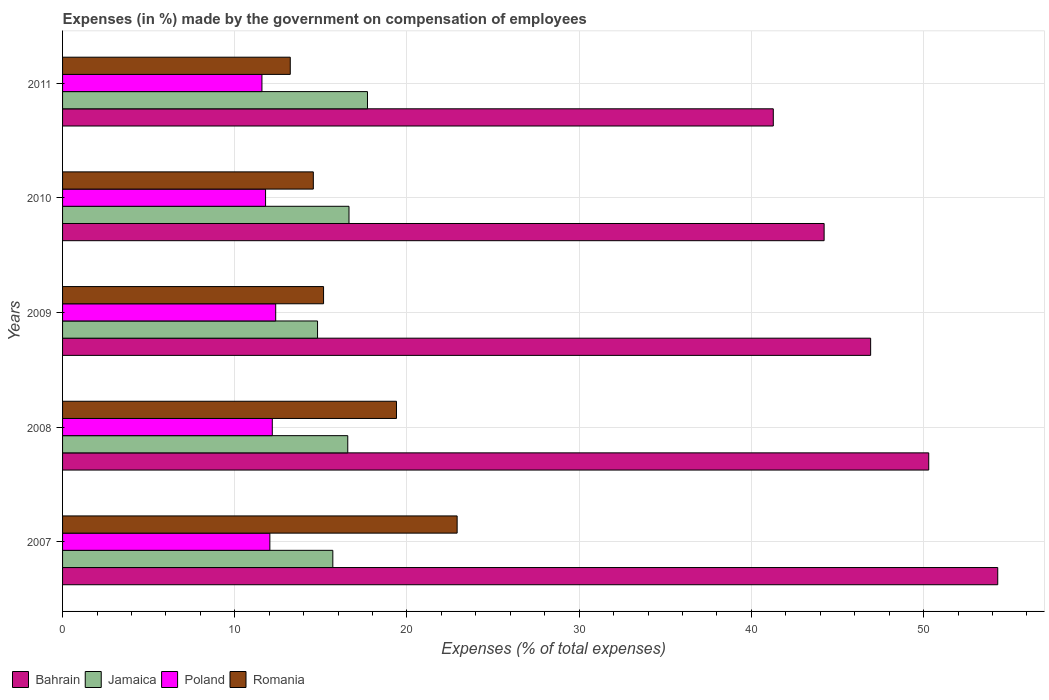How many different coloured bars are there?
Your response must be concise. 4. How many groups of bars are there?
Give a very brief answer. 5. Are the number of bars per tick equal to the number of legend labels?
Your answer should be compact. Yes. Are the number of bars on each tick of the Y-axis equal?
Ensure brevity in your answer.  Yes. How many bars are there on the 2nd tick from the top?
Your response must be concise. 4. In how many cases, is the number of bars for a given year not equal to the number of legend labels?
Offer a terse response. 0. What is the percentage of expenses made by the government on compensation of employees in Bahrain in 2009?
Offer a very short reply. 46.93. Across all years, what is the maximum percentage of expenses made by the government on compensation of employees in Jamaica?
Make the answer very short. 17.71. Across all years, what is the minimum percentage of expenses made by the government on compensation of employees in Bahrain?
Provide a succinct answer. 41.27. What is the total percentage of expenses made by the government on compensation of employees in Poland in the graph?
Provide a succinct answer. 59.96. What is the difference between the percentage of expenses made by the government on compensation of employees in Romania in 2008 and that in 2011?
Offer a very short reply. 6.17. What is the difference between the percentage of expenses made by the government on compensation of employees in Poland in 2010 and the percentage of expenses made by the government on compensation of employees in Romania in 2007?
Provide a short and direct response. -11.13. What is the average percentage of expenses made by the government on compensation of employees in Bahrain per year?
Offer a very short reply. 47.41. In the year 2011, what is the difference between the percentage of expenses made by the government on compensation of employees in Bahrain and percentage of expenses made by the government on compensation of employees in Romania?
Offer a terse response. 28.05. What is the ratio of the percentage of expenses made by the government on compensation of employees in Jamaica in 2009 to that in 2011?
Provide a short and direct response. 0.84. Is the difference between the percentage of expenses made by the government on compensation of employees in Bahrain in 2008 and 2010 greater than the difference between the percentage of expenses made by the government on compensation of employees in Romania in 2008 and 2010?
Your answer should be very brief. Yes. What is the difference between the highest and the second highest percentage of expenses made by the government on compensation of employees in Poland?
Provide a short and direct response. 0.2. What is the difference between the highest and the lowest percentage of expenses made by the government on compensation of employees in Poland?
Give a very brief answer. 0.8. In how many years, is the percentage of expenses made by the government on compensation of employees in Poland greater than the average percentage of expenses made by the government on compensation of employees in Poland taken over all years?
Your answer should be compact. 3. Is the sum of the percentage of expenses made by the government on compensation of employees in Romania in 2008 and 2009 greater than the maximum percentage of expenses made by the government on compensation of employees in Bahrain across all years?
Your answer should be compact. No. How many bars are there?
Ensure brevity in your answer.  20. Are all the bars in the graph horizontal?
Your answer should be compact. Yes. How many years are there in the graph?
Your answer should be very brief. 5. What is the difference between two consecutive major ticks on the X-axis?
Provide a short and direct response. 10. Does the graph contain any zero values?
Provide a succinct answer. No. How are the legend labels stacked?
Make the answer very short. Horizontal. What is the title of the graph?
Offer a very short reply. Expenses (in %) made by the government on compensation of employees. What is the label or title of the X-axis?
Offer a terse response. Expenses (% of total expenses). What is the label or title of the Y-axis?
Your answer should be compact. Years. What is the Expenses (% of total expenses) of Bahrain in 2007?
Ensure brevity in your answer.  54.31. What is the Expenses (% of total expenses) in Jamaica in 2007?
Make the answer very short. 15.69. What is the Expenses (% of total expenses) in Poland in 2007?
Give a very brief answer. 12.04. What is the Expenses (% of total expenses) in Romania in 2007?
Offer a very short reply. 22.91. What is the Expenses (% of total expenses) of Bahrain in 2008?
Offer a very short reply. 50.3. What is the Expenses (% of total expenses) of Jamaica in 2008?
Give a very brief answer. 16.56. What is the Expenses (% of total expenses) in Poland in 2008?
Your answer should be very brief. 12.18. What is the Expenses (% of total expenses) in Romania in 2008?
Your response must be concise. 19.39. What is the Expenses (% of total expenses) of Bahrain in 2009?
Offer a terse response. 46.93. What is the Expenses (% of total expenses) in Jamaica in 2009?
Keep it short and to the point. 14.81. What is the Expenses (% of total expenses) in Poland in 2009?
Offer a very short reply. 12.38. What is the Expenses (% of total expenses) of Romania in 2009?
Offer a very short reply. 15.16. What is the Expenses (% of total expenses) in Bahrain in 2010?
Give a very brief answer. 44.22. What is the Expenses (% of total expenses) of Jamaica in 2010?
Offer a very short reply. 16.63. What is the Expenses (% of total expenses) of Poland in 2010?
Ensure brevity in your answer.  11.79. What is the Expenses (% of total expenses) in Romania in 2010?
Your answer should be very brief. 14.56. What is the Expenses (% of total expenses) of Bahrain in 2011?
Provide a short and direct response. 41.27. What is the Expenses (% of total expenses) of Jamaica in 2011?
Your response must be concise. 17.71. What is the Expenses (% of total expenses) in Poland in 2011?
Provide a succinct answer. 11.58. What is the Expenses (% of total expenses) of Romania in 2011?
Provide a succinct answer. 13.22. Across all years, what is the maximum Expenses (% of total expenses) in Bahrain?
Your response must be concise. 54.31. Across all years, what is the maximum Expenses (% of total expenses) of Jamaica?
Offer a very short reply. 17.71. Across all years, what is the maximum Expenses (% of total expenses) in Poland?
Give a very brief answer. 12.38. Across all years, what is the maximum Expenses (% of total expenses) of Romania?
Ensure brevity in your answer.  22.91. Across all years, what is the minimum Expenses (% of total expenses) of Bahrain?
Offer a terse response. 41.27. Across all years, what is the minimum Expenses (% of total expenses) in Jamaica?
Your answer should be very brief. 14.81. Across all years, what is the minimum Expenses (% of total expenses) in Poland?
Your answer should be compact. 11.58. Across all years, what is the minimum Expenses (% of total expenses) of Romania?
Your answer should be very brief. 13.22. What is the total Expenses (% of total expenses) in Bahrain in the graph?
Ensure brevity in your answer.  237.03. What is the total Expenses (% of total expenses) of Jamaica in the graph?
Make the answer very short. 81.4. What is the total Expenses (% of total expenses) in Poland in the graph?
Your answer should be compact. 59.96. What is the total Expenses (% of total expenses) in Romania in the graph?
Keep it short and to the point. 85.24. What is the difference between the Expenses (% of total expenses) of Bahrain in 2007 and that in 2008?
Your answer should be compact. 4.01. What is the difference between the Expenses (% of total expenses) of Jamaica in 2007 and that in 2008?
Ensure brevity in your answer.  -0.87. What is the difference between the Expenses (% of total expenses) of Poland in 2007 and that in 2008?
Give a very brief answer. -0.14. What is the difference between the Expenses (% of total expenses) of Romania in 2007 and that in 2008?
Your response must be concise. 3.52. What is the difference between the Expenses (% of total expenses) in Bahrain in 2007 and that in 2009?
Keep it short and to the point. 7.38. What is the difference between the Expenses (% of total expenses) of Jamaica in 2007 and that in 2009?
Give a very brief answer. 0.89. What is the difference between the Expenses (% of total expenses) in Poland in 2007 and that in 2009?
Your response must be concise. -0.34. What is the difference between the Expenses (% of total expenses) of Romania in 2007 and that in 2009?
Provide a short and direct response. 7.76. What is the difference between the Expenses (% of total expenses) in Bahrain in 2007 and that in 2010?
Make the answer very short. 10.08. What is the difference between the Expenses (% of total expenses) of Jamaica in 2007 and that in 2010?
Offer a terse response. -0.94. What is the difference between the Expenses (% of total expenses) in Poland in 2007 and that in 2010?
Offer a terse response. 0.25. What is the difference between the Expenses (% of total expenses) of Romania in 2007 and that in 2010?
Give a very brief answer. 8.35. What is the difference between the Expenses (% of total expenses) of Bahrain in 2007 and that in 2011?
Provide a succinct answer. 13.03. What is the difference between the Expenses (% of total expenses) of Jamaica in 2007 and that in 2011?
Keep it short and to the point. -2.01. What is the difference between the Expenses (% of total expenses) in Poland in 2007 and that in 2011?
Your response must be concise. 0.46. What is the difference between the Expenses (% of total expenses) in Romania in 2007 and that in 2011?
Provide a short and direct response. 9.69. What is the difference between the Expenses (% of total expenses) in Bahrain in 2008 and that in 2009?
Provide a succinct answer. 3.37. What is the difference between the Expenses (% of total expenses) in Jamaica in 2008 and that in 2009?
Your answer should be compact. 1.75. What is the difference between the Expenses (% of total expenses) of Poland in 2008 and that in 2009?
Give a very brief answer. -0.2. What is the difference between the Expenses (% of total expenses) in Romania in 2008 and that in 2009?
Ensure brevity in your answer.  4.23. What is the difference between the Expenses (% of total expenses) in Bahrain in 2008 and that in 2010?
Offer a terse response. 6.08. What is the difference between the Expenses (% of total expenses) of Jamaica in 2008 and that in 2010?
Keep it short and to the point. -0.07. What is the difference between the Expenses (% of total expenses) in Poland in 2008 and that in 2010?
Offer a terse response. 0.39. What is the difference between the Expenses (% of total expenses) in Romania in 2008 and that in 2010?
Keep it short and to the point. 4.83. What is the difference between the Expenses (% of total expenses) in Bahrain in 2008 and that in 2011?
Give a very brief answer. 9.03. What is the difference between the Expenses (% of total expenses) of Jamaica in 2008 and that in 2011?
Give a very brief answer. -1.15. What is the difference between the Expenses (% of total expenses) of Poland in 2008 and that in 2011?
Provide a short and direct response. 0.6. What is the difference between the Expenses (% of total expenses) of Romania in 2008 and that in 2011?
Your answer should be very brief. 6.17. What is the difference between the Expenses (% of total expenses) in Bahrain in 2009 and that in 2010?
Provide a short and direct response. 2.7. What is the difference between the Expenses (% of total expenses) of Jamaica in 2009 and that in 2010?
Your answer should be compact. -1.83. What is the difference between the Expenses (% of total expenses) in Poland in 2009 and that in 2010?
Give a very brief answer. 0.59. What is the difference between the Expenses (% of total expenses) of Romania in 2009 and that in 2010?
Your answer should be very brief. 0.59. What is the difference between the Expenses (% of total expenses) of Bahrain in 2009 and that in 2011?
Your answer should be compact. 5.65. What is the difference between the Expenses (% of total expenses) of Poland in 2009 and that in 2011?
Offer a terse response. 0.8. What is the difference between the Expenses (% of total expenses) of Romania in 2009 and that in 2011?
Your response must be concise. 1.93. What is the difference between the Expenses (% of total expenses) in Bahrain in 2010 and that in 2011?
Your response must be concise. 2.95. What is the difference between the Expenses (% of total expenses) of Jamaica in 2010 and that in 2011?
Provide a short and direct response. -1.07. What is the difference between the Expenses (% of total expenses) of Poland in 2010 and that in 2011?
Make the answer very short. 0.21. What is the difference between the Expenses (% of total expenses) in Romania in 2010 and that in 2011?
Offer a very short reply. 1.34. What is the difference between the Expenses (% of total expenses) in Bahrain in 2007 and the Expenses (% of total expenses) in Jamaica in 2008?
Provide a short and direct response. 37.74. What is the difference between the Expenses (% of total expenses) in Bahrain in 2007 and the Expenses (% of total expenses) in Poland in 2008?
Your response must be concise. 42.13. What is the difference between the Expenses (% of total expenses) of Bahrain in 2007 and the Expenses (% of total expenses) of Romania in 2008?
Offer a very short reply. 34.92. What is the difference between the Expenses (% of total expenses) in Jamaica in 2007 and the Expenses (% of total expenses) in Poland in 2008?
Your response must be concise. 3.52. What is the difference between the Expenses (% of total expenses) of Jamaica in 2007 and the Expenses (% of total expenses) of Romania in 2008?
Provide a succinct answer. -3.7. What is the difference between the Expenses (% of total expenses) in Poland in 2007 and the Expenses (% of total expenses) in Romania in 2008?
Provide a succinct answer. -7.35. What is the difference between the Expenses (% of total expenses) in Bahrain in 2007 and the Expenses (% of total expenses) in Jamaica in 2009?
Offer a very short reply. 39.5. What is the difference between the Expenses (% of total expenses) in Bahrain in 2007 and the Expenses (% of total expenses) in Poland in 2009?
Your answer should be very brief. 41.93. What is the difference between the Expenses (% of total expenses) in Bahrain in 2007 and the Expenses (% of total expenses) in Romania in 2009?
Give a very brief answer. 39.15. What is the difference between the Expenses (% of total expenses) in Jamaica in 2007 and the Expenses (% of total expenses) in Poland in 2009?
Your response must be concise. 3.32. What is the difference between the Expenses (% of total expenses) of Jamaica in 2007 and the Expenses (% of total expenses) of Romania in 2009?
Provide a short and direct response. 0.54. What is the difference between the Expenses (% of total expenses) of Poland in 2007 and the Expenses (% of total expenses) of Romania in 2009?
Provide a succinct answer. -3.12. What is the difference between the Expenses (% of total expenses) of Bahrain in 2007 and the Expenses (% of total expenses) of Jamaica in 2010?
Your answer should be very brief. 37.67. What is the difference between the Expenses (% of total expenses) of Bahrain in 2007 and the Expenses (% of total expenses) of Poland in 2010?
Ensure brevity in your answer.  42.52. What is the difference between the Expenses (% of total expenses) of Bahrain in 2007 and the Expenses (% of total expenses) of Romania in 2010?
Provide a succinct answer. 39.74. What is the difference between the Expenses (% of total expenses) of Jamaica in 2007 and the Expenses (% of total expenses) of Poland in 2010?
Keep it short and to the point. 3.91. What is the difference between the Expenses (% of total expenses) of Jamaica in 2007 and the Expenses (% of total expenses) of Romania in 2010?
Your answer should be very brief. 1.13. What is the difference between the Expenses (% of total expenses) in Poland in 2007 and the Expenses (% of total expenses) in Romania in 2010?
Give a very brief answer. -2.52. What is the difference between the Expenses (% of total expenses) in Bahrain in 2007 and the Expenses (% of total expenses) in Jamaica in 2011?
Make the answer very short. 36.6. What is the difference between the Expenses (% of total expenses) of Bahrain in 2007 and the Expenses (% of total expenses) of Poland in 2011?
Provide a short and direct response. 42.73. What is the difference between the Expenses (% of total expenses) in Bahrain in 2007 and the Expenses (% of total expenses) in Romania in 2011?
Provide a short and direct response. 41.08. What is the difference between the Expenses (% of total expenses) of Jamaica in 2007 and the Expenses (% of total expenses) of Poland in 2011?
Make the answer very short. 4.12. What is the difference between the Expenses (% of total expenses) of Jamaica in 2007 and the Expenses (% of total expenses) of Romania in 2011?
Your answer should be very brief. 2.47. What is the difference between the Expenses (% of total expenses) in Poland in 2007 and the Expenses (% of total expenses) in Romania in 2011?
Your answer should be compact. -1.19. What is the difference between the Expenses (% of total expenses) in Bahrain in 2008 and the Expenses (% of total expenses) in Jamaica in 2009?
Your response must be concise. 35.49. What is the difference between the Expenses (% of total expenses) in Bahrain in 2008 and the Expenses (% of total expenses) in Poland in 2009?
Your answer should be compact. 37.92. What is the difference between the Expenses (% of total expenses) in Bahrain in 2008 and the Expenses (% of total expenses) in Romania in 2009?
Your answer should be very brief. 35.14. What is the difference between the Expenses (% of total expenses) in Jamaica in 2008 and the Expenses (% of total expenses) in Poland in 2009?
Your response must be concise. 4.18. What is the difference between the Expenses (% of total expenses) in Jamaica in 2008 and the Expenses (% of total expenses) in Romania in 2009?
Provide a succinct answer. 1.41. What is the difference between the Expenses (% of total expenses) of Poland in 2008 and the Expenses (% of total expenses) of Romania in 2009?
Provide a short and direct response. -2.98. What is the difference between the Expenses (% of total expenses) in Bahrain in 2008 and the Expenses (% of total expenses) in Jamaica in 2010?
Offer a very short reply. 33.67. What is the difference between the Expenses (% of total expenses) in Bahrain in 2008 and the Expenses (% of total expenses) in Poland in 2010?
Provide a succinct answer. 38.51. What is the difference between the Expenses (% of total expenses) in Bahrain in 2008 and the Expenses (% of total expenses) in Romania in 2010?
Your answer should be compact. 35.74. What is the difference between the Expenses (% of total expenses) in Jamaica in 2008 and the Expenses (% of total expenses) in Poland in 2010?
Keep it short and to the point. 4.77. What is the difference between the Expenses (% of total expenses) in Jamaica in 2008 and the Expenses (% of total expenses) in Romania in 2010?
Provide a short and direct response. 2. What is the difference between the Expenses (% of total expenses) of Poland in 2008 and the Expenses (% of total expenses) of Romania in 2010?
Provide a succinct answer. -2.38. What is the difference between the Expenses (% of total expenses) in Bahrain in 2008 and the Expenses (% of total expenses) in Jamaica in 2011?
Your answer should be compact. 32.59. What is the difference between the Expenses (% of total expenses) of Bahrain in 2008 and the Expenses (% of total expenses) of Poland in 2011?
Ensure brevity in your answer.  38.72. What is the difference between the Expenses (% of total expenses) of Bahrain in 2008 and the Expenses (% of total expenses) of Romania in 2011?
Make the answer very short. 37.08. What is the difference between the Expenses (% of total expenses) in Jamaica in 2008 and the Expenses (% of total expenses) in Poland in 2011?
Provide a short and direct response. 4.98. What is the difference between the Expenses (% of total expenses) in Jamaica in 2008 and the Expenses (% of total expenses) in Romania in 2011?
Your answer should be very brief. 3.34. What is the difference between the Expenses (% of total expenses) of Poland in 2008 and the Expenses (% of total expenses) of Romania in 2011?
Keep it short and to the point. -1.04. What is the difference between the Expenses (% of total expenses) in Bahrain in 2009 and the Expenses (% of total expenses) in Jamaica in 2010?
Your answer should be very brief. 30.29. What is the difference between the Expenses (% of total expenses) of Bahrain in 2009 and the Expenses (% of total expenses) of Poland in 2010?
Provide a succinct answer. 35.14. What is the difference between the Expenses (% of total expenses) in Bahrain in 2009 and the Expenses (% of total expenses) in Romania in 2010?
Ensure brevity in your answer.  32.36. What is the difference between the Expenses (% of total expenses) of Jamaica in 2009 and the Expenses (% of total expenses) of Poland in 2010?
Provide a short and direct response. 3.02. What is the difference between the Expenses (% of total expenses) of Jamaica in 2009 and the Expenses (% of total expenses) of Romania in 2010?
Provide a short and direct response. 0.25. What is the difference between the Expenses (% of total expenses) of Poland in 2009 and the Expenses (% of total expenses) of Romania in 2010?
Your response must be concise. -2.18. What is the difference between the Expenses (% of total expenses) in Bahrain in 2009 and the Expenses (% of total expenses) in Jamaica in 2011?
Make the answer very short. 29.22. What is the difference between the Expenses (% of total expenses) of Bahrain in 2009 and the Expenses (% of total expenses) of Poland in 2011?
Your response must be concise. 35.35. What is the difference between the Expenses (% of total expenses) in Bahrain in 2009 and the Expenses (% of total expenses) in Romania in 2011?
Ensure brevity in your answer.  33.7. What is the difference between the Expenses (% of total expenses) of Jamaica in 2009 and the Expenses (% of total expenses) of Poland in 2011?
Offer a very short reply. 3.23. What is the difference between the Expenses (% of total expenses) in Jamaica in 2009 and the Expenses (% of total expenses) in Romania in 2011?
Keep it short and to the point. 1.58. What is the difference between the Expenses (% of total expenses) of Poland in 2009 and the Expenses (% of total expenses) of Romania in 2011?
Provide a succinct answer. -0.85. What is the difference between the Expenses (% of total expenses) of Bahrain in 2010 and the Expenses (% of total expenses) of Jamaica in 2011?
Ensure brevity in your answer.  26.52. What is the difference between the Expenses (% of total expenses) of Bahrain in 2010 and the Expenses (% of total expenses) of Poland in 2011?
Keep it short and to the point. 32.65. What is the difference between the Expenses (% of total expenses) of Bahrain in 2010 and the Expenses (% of total expenses) of Romania in 2011?
Keep it short and to the point. 31. What is the difference between the Expenses (% of total expenses) of Jamaica in 2010 and the Expenses (% of total expenses) of Poland in 2011?
Keep it short and to the point. 5.06. What is the difference between the Expenses (% of total expenses) of Jamaica in 2010 and the Expenses (% of total expenses) of Romania in 2011?
Give a very brief answer. 3.41. What is the difference between the Expenses (% of total expenses) in Poland in 2010 and the Expenses (% of total expenses) in Romania in 2011?
Ensure brevity in your answer.  -1.43. What is the average Expenses (% of total expenses) in Bahrain per year?
Offer a very short reply. 47.41. What is the average Expenses (% of total expenses) of Jamaica per year?
Your response must be concise. 16.28. What is the average Expenses (% of total expenses) of Poland per year?
Offer a very short reply. 11.99. What is the average Expenses (% of total expenses) in Romania per year?
Your response must be concise. 17.05. In the year 2007, what is the difference between the Expenses (% of total expenses) in Bahrain and Expenses (% of total expenses) in Jamaica?
Provide a succinct answer. 38.61. In the year 2007, what is the difference between the Expenses (% of total expenses) of Bahrain and Expenses (% of total expenses) of Poland?
Your answer should be compact. 42.27. In the year 2007, what is the difference between the Expenses (% of total expenses) in Bahrain and Expenses (% of total expenses) in Romania?
Your answer should be very brief. 31.39. In the year 2007, what is the difference between the Expenses (% of total expenses) in Jamaica and Expenses (% of total expenses) in Poland?
Your answer should be very brief. 3.66. In the year 2007, what is the difference between the Expenses (% of total expenses) of Jamaica and Expenses (% of total expenses) of Romania?
Your answer should be compact. -7.22. In the year 2007, what is the difference between the Expenses (% of total expenses) in Poland and Expenses (% of total expenses) in Romania?
Provide a succinct answer. -10.88. In the year 2008, what is the difference between the Expenses (% of total expenses) of Bahrain and Expenses (% of total expenses) of Jamaica?
Ensure brevity in your answer.  33.74. In the year 2008, what is the difference between the Expenses (% of total expenses) in Bahrain and Expenses (% of total expenses) in Poland?
Offer a terse response. 38.12. In the year 2008, what is the difference between the Expenses (% of total expenses) in Bahrain and Expenses (% of total expenses) in Romania?
Make the answer very short. 30.91. In the year 2008, what is the difference between the Expenses (% of total expenses) in Jamaica and Expenses (% of total expenses) in Poland?
Offer a very short reply. 4.38. In the year 2008, what is the difference between the Expenses (% of total expenses) in Jamaica and Expenses (% of total expenses) in Romania?
Your answer should be compact. -2.83. In the year 2008, what is the difference between the Expenses (% of total expenses) in Poland and Expenses (% of total expenses) in Romania?
Your response must be concise. -7.21. In the year 2009, what is the difference between the Expenses (% of total expenses) in Bahrain and Expenses (% of total expenses) in Jamaica?
Ensure brevity in your answer.  32.12. In the year 2009, what is the difference between the Expenses (% of total expenses) in Bahrain and Expenses (% of total expenses) in Poland?
Your answer should be very brief. 34.55. In the year 2009, what is the difference between the Expenses (% of total expenses) in Bahrain and Expenses (% of total expenses) in Romania?
Offer a very short reply. 31.77. In the year 2009, what is the difference between the Expenses (% of total expenses) of Jamaica and Expenses (% of total expenses) of Poland?
Make the answer very short. 2.43. In the year 2009, what is the difference between the Expenses (% of total expenses) of Jamaica and Expenses (% of total expenses) of Romania?
Your response must be concise. -0.35. In the year 2009, what is the difference between the Expenses (% of total expenses) of Poland and Expenses (% of total expenses) of Romania?
Ensure brevity in your answer.  -2.78. In the year 2010, what is the difference between the Expenses (% of total expenses) in Bahrain and Expenses (% of total expenses) in Jamaica?
Offer a terse response. 27.59. In the year 2010, what is the difference between the Expenses (% of total expenses) in Bahrain and Expenses (% of total expenses) in Poland?
Offer a very short reply. 32.44. In the year 2010, what is the difference between the Expenses (% of total expenses) of Bahrain and Expenses (% of total expenses) of Romania?
Give a very brief answer. 29.66. In the year 2010, what is the difference between the Expenses (% of total expenses) of Jamaica and Expenses (% of total expenses) of Poland?
Your answer should be compact. 4.85. In the year 2010, what is the difference between the Expenses (% of total expenses) of Jamaica and Expenses (% of total expenses) of Romania?
Your answer should be compact. 2.07. In the year 2010, what is the difference between the Expenses (% of total expenses) in Poland and Expenses (% of total expenses) in Romania?
Provide a short and direct response. -2.77. In the year 2011, what is the difference between the Expenses (% of total expenses) in Bahrain and Expenses (% of total expenses) in Jamaica?
Your answer should be very brief. 23.57. In the year 2011, what is the difference between the Expenses (% of total expenses) of Bahrain and Expenses (% of total expenses) of Poland?
Offer a terse response. 29.7. In the year 2011, what is the difference between the Expenses (% of total expenses) in Bahrain and Expenses (% of total expenses) in Romania?
Your response must be concise. 28.05. In the year 2011, what is the difference between the Expenses (% of total expenses) in Jamaica and Expenses (% of total expenses) in Poland?
Make the answer very short. 6.13. In the year 2011, what is the difference between the Expenses (% of total expenses) of Jamaica and Expenses (% of total expenses) of Romania?
Provide a short and direct response. 4.48. In the year 2011, what is the difference between the Expenses (% of total expenses) of Poland and Expenses (% of total expenses) of Romania?
Offer a terse response. -1.65. What is the ratio of the Expenses (% of total expenses) in Bahrain in 2007 to that in 2008?
Give a very brief answer. 1.08. What is the ratio of the Expenses (% of total expenses) in Jamaica in 2007 to that in 2008?
Provide a short and direct response. 0.95. What is the ratio of the Expenses (% of total expenses) in Poland in 2007 to that in 2008?
Ensure brevity in your answer.  0.99. What is the ratio of the Expenses (% of total expenses) of Romania in 2007 to that in 2008?
Provide a short and direct response. 1.18. What is the ratio of the Expenses (% of total expenses) of Bahrain in 2007 to that in 2009?
Offer a terse response. 1.16. What is the ratio of the Expenses (% of total expenses) in Jamaica in 2007 to that in 2009?
Keep it short and to the point. 1.06. What is the ratio of the Expenses (% of total expenses) in Poland in 2007 to that in 2009?
Keep it short and to the point. 0.97. What is the ratio of the Expenses (% of total expenses) of Romania in 2007 to that in 2009?
Give a very brief answer. 1.51. What is the ratio of the Expenses (% of total expenses) in Bahrain in 2007 to that in 2010?
Your answer should be very brief. 1.23. What is the ratio of the Expenses (% of total expenses) of Jamaica in 2007 to that in 2010?
Provide a succinct answer. 0.94. What is the ratio of the Expenses (% of total expenses) in Poland in 2007 to that in 2010?
Offer a terse response. 1.02. What is the ratio of the Expenses (% of total expenses) of Romania in 2007 to that in 2010?
Ensure brevity in your answer.  1.57. What is the ratio of the Expenses (% of total expenses) in Bahrain in 2007 to that in 2011?
Your answer should be compact. 1.32. What is the ratio of the Expenses (% of total expenses) of Jamaica in 2007 to that in 2011?
Give a very brief answer. 0.89. What is the ratio of the Expenses (% of total expenses) of Poland in 2007 to that in 2011?
Your answer should be compact. 1.04. What is the ratio of the Expenses (% of total expenses) of Romania in 2007 to that in 2011?
Your answer should be compact. 1.73. What is the ratio of the Expenses (% of total expenses) of Bahrain in 2008 to that in 2009?
Your response must be concise. 1.07. What is the ratio of the Expenses (% of total expenses) in Jamaica in 2008 to that in 2009?
Keep it short and to the point. 1.12. What is the ratio of the Expenses (% of total expenses) in Poland in 2008 to that in 2009?
Your answer should be compact. 0.98. What is the ratio of the Expenses (% of total expenses) of Romania in 2008 to that in 2009?
Keep it short and to the point. 1.28. What is the ratio of the Expenses (% of total expenses) of Bahrain in 2008 to that in 2010?
Ensure brevity in your answer.  1.14. What is the ratio of the Expenses (% of total expenses) of Poland in 2008 to that in 2010?
Keep it short and to the point. 1.03. What is the ratio of the Expenses (% of total expenses) in Romania in 2008 to that in 2010?
Your answer should be very brief. 1.33. What is the ratio of the Expenses (% of total expenses) in Bahrain in 2008 to that in 2011?
Ensure brevity in your answer.  1.22. What is the ratio of the Expenses (% of total expenses) in Jamaica in 2008 to that in 2011?
Give a very brief answer. 0.94. What is the ratio of the Expenses (% of total expenses) in Poland in 2008 to that in 2011?
Ensure brevity in your answer.  1.05. What is the ratio of the Expenses (% of total expenses) of Romania in 2008 to that in 2011?
Make the answer very short. 1.47. What is the ratio of the Expenses (% of total expenses) in Bahrain in 2009 to that in 2010?
Offer a very short reply. 1.06. What is the ratio of the Expenses (% of total expenses) of Jamaica in 2009 to that in 2010?
Your response must be concise. 0.89. What is the ratio of the Expenses (% of total expenses) in Poland in 2009 to that in 2010?
Offer a terse response. 1.05. What is the ratio of the Expenses (% of total expenses) in Romania in 2009 to that in 2010?
Offer a very short reply. 1.04. What is the ratio of the Expenses (% of total expenses) in Bahrain in 2009 to that in 2011?
Ensure brevity in your answer.  1.14. What is the ratio of the Expenses (% of total expenses) of Jamaica in 2009 to that in 2011?
Provide a short and direct response. 0.84. What is the ratio of the Expenses (% of total expenses) in Poland in 2009 to that in 2011?
Your answer should be compact. 1.07. What is the ratio of the Expenses (% of total expenses) in Romania in 2009 to that in 2011?
Provide a short and direct response. 1.15. What is the ratio of the Expenses (% of total expenses) of Bahrain in 2010 to that in 2011?
Your answer should be very brief. 1.07. What is the ratio of the Expenses (% of total expenses) in Jamaica in 2010 to that in 2011?
Your response must be concise. 0.94. What is the ratio of the Expenses (% of total expenses) in Poland in 2010 to that in 2011?
Ensure brevity in your answer.  1.02. What is the ratio of the Expenses (% of total expenses) of Romania in 2010 to that in 2011?
Your answer should be compact. 1.1. What is the difference between the highest and the second highest Expenses (% of total expenses) in Bahrain?
Offer a very short reply. 4.01. What is the difference between the highest and the second highest Expenses (% of total expenses) in Jamaica?
Provide a succinct answer. 1.07. What is the difference between the highest and the second highest Expenses (% of total expenses) in Poland?
Your answer should be compact. 0.2. What is the difference between the highest and the second highest Expenses (% of total expenses) in Romania?
Keep it short and to the point. 3.52. What is the difference between the highest and the lowest Expenses (% of total expenses) in Bahrain?
Provide a succinct answer. 13.03. What is the difference between the highest and the lowest Expenses (% of total expenses) in Poland?
Make the answer very short. 0.8. What is the difference between the highest and the lowest Expenses (% of total expenses) of Romania?
Offer a very short reply. 9.69. 